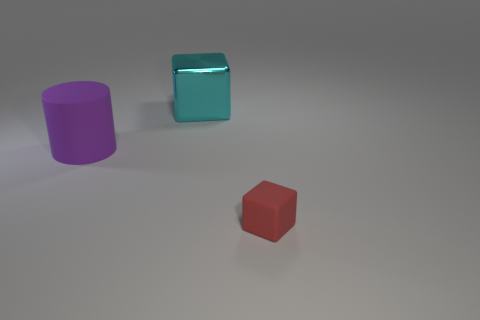What is the size of the rubber object that is left of the cube left of the rubber cube?
Offer a very short reply. Large. Is there anything else that is the same size as the red rubber object?
Make the answer very short. No. Is there a large cylinder that has the same material as the tiny red cube?
Provide a succinct answer. Yes. Are there more shiny cubes that are behind the large rubber cylinder than big purple objects in front of the tiny cube?
Ensure brevity in your answer.  Yes. What is the size of the red block?
Your response must be concise. Small. What is the shape of the matte object that is on the left side of the tiny rubber object?
Provide a succinct answer. Cylinder. Does the big cyan metal thing have the same shape as the small red object?
Give a very brief answer. Yes. Is the number of big rubber objects that are behind the large cyan metal cube the same as the number of big gray spheres?
Make the answer very short. Yes. What shape is the large cyan metal thing?
Keep it short and to the point. Cube. Is there anything else that is the same color as the tiny rubber thing?
Offer a very short reply. No. 